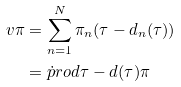Convert formula to latex. <formula><loc_0><loc_0><loc_500><loc_500>\ v { \pi } & = \sum _ { n = 1 } ^ { N } \pi _ { n } ( \tau - d _ { n } ( \tau ) ) \\ & = \dot { p } r o d { \tau - d ( \tau ) } { \pi }</formula> 